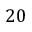<formula> <loc_0><loc_0><loc_500><loc_500>2 0</formula> 